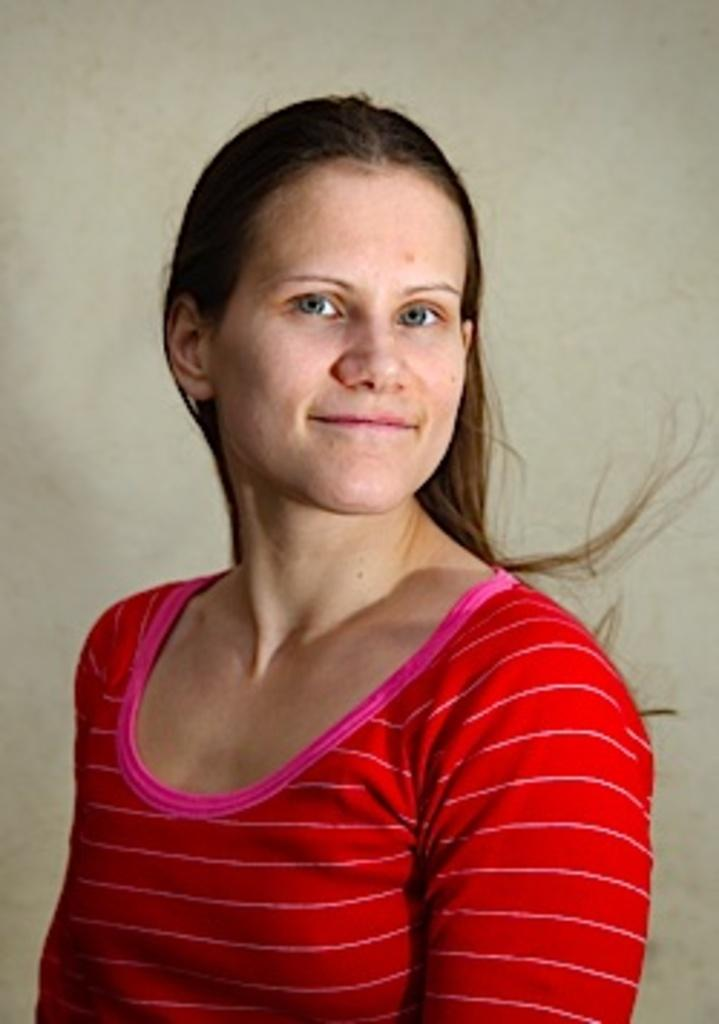Who is the main subject in the image? There is a lady in the center of the image. What can be seen in the background of the image? There is a wall in the background of the image. What type of beef is the lady cooking in the image? There is no beef or cooking activity present in the image; it only features a lady and a wall in the background. What kind of trousers is the lady wearing in the image? The provided facts do not mention the lady's clothing, so we cannot determine the type of trousers she is wearing. 